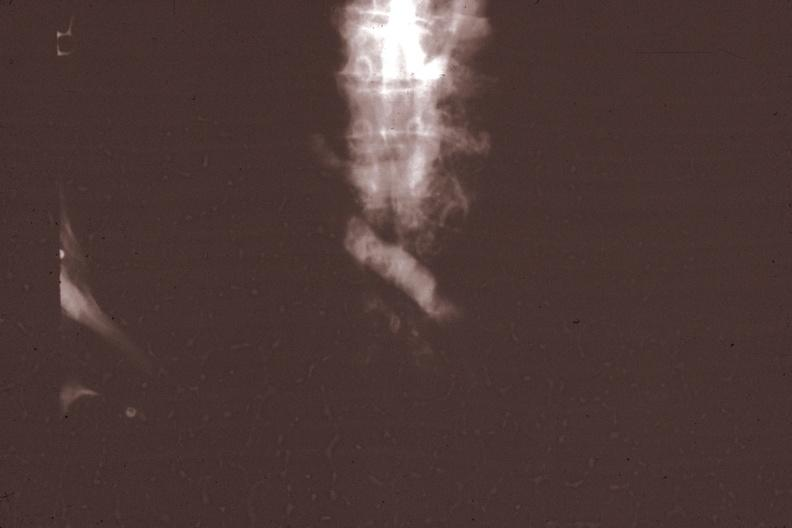what does x-ray super cava venogram showing obstruction at level of entrance of innominate vein gross photo of tumor in this file correspond?
Answer the question using a single word or phrase. File corresponds 